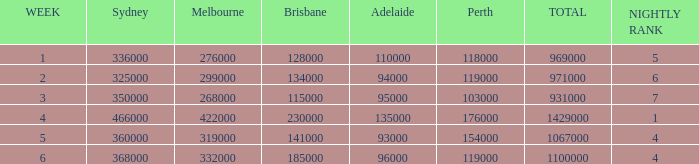What was the overall rating during the third week? 931000.0. 